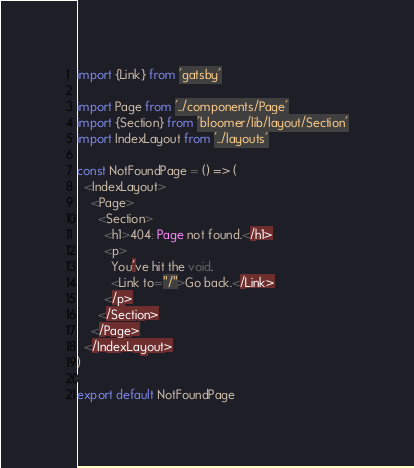Convert code to text. <code><loc_0><loc_0><loc_500><loc_500><_TypeScript_>import {Link} from 'gatsby'

import Page from '../components/Page'
import {Section} from 'bloomer/lib/layout/Section'
import IndexLayout from '../layouts'

const NotFoundPage = () => (
  <IndexLayout>
    <Page>
      <Section>
        <h1>404: Page not found.</h1>
        <p>
          You've hit the void.
          <Link to="/">Go back.</Link>
        </p>
      </Section>
    </Page>
  </IndexLayout>
)

export default NotFoundPage
</code> 